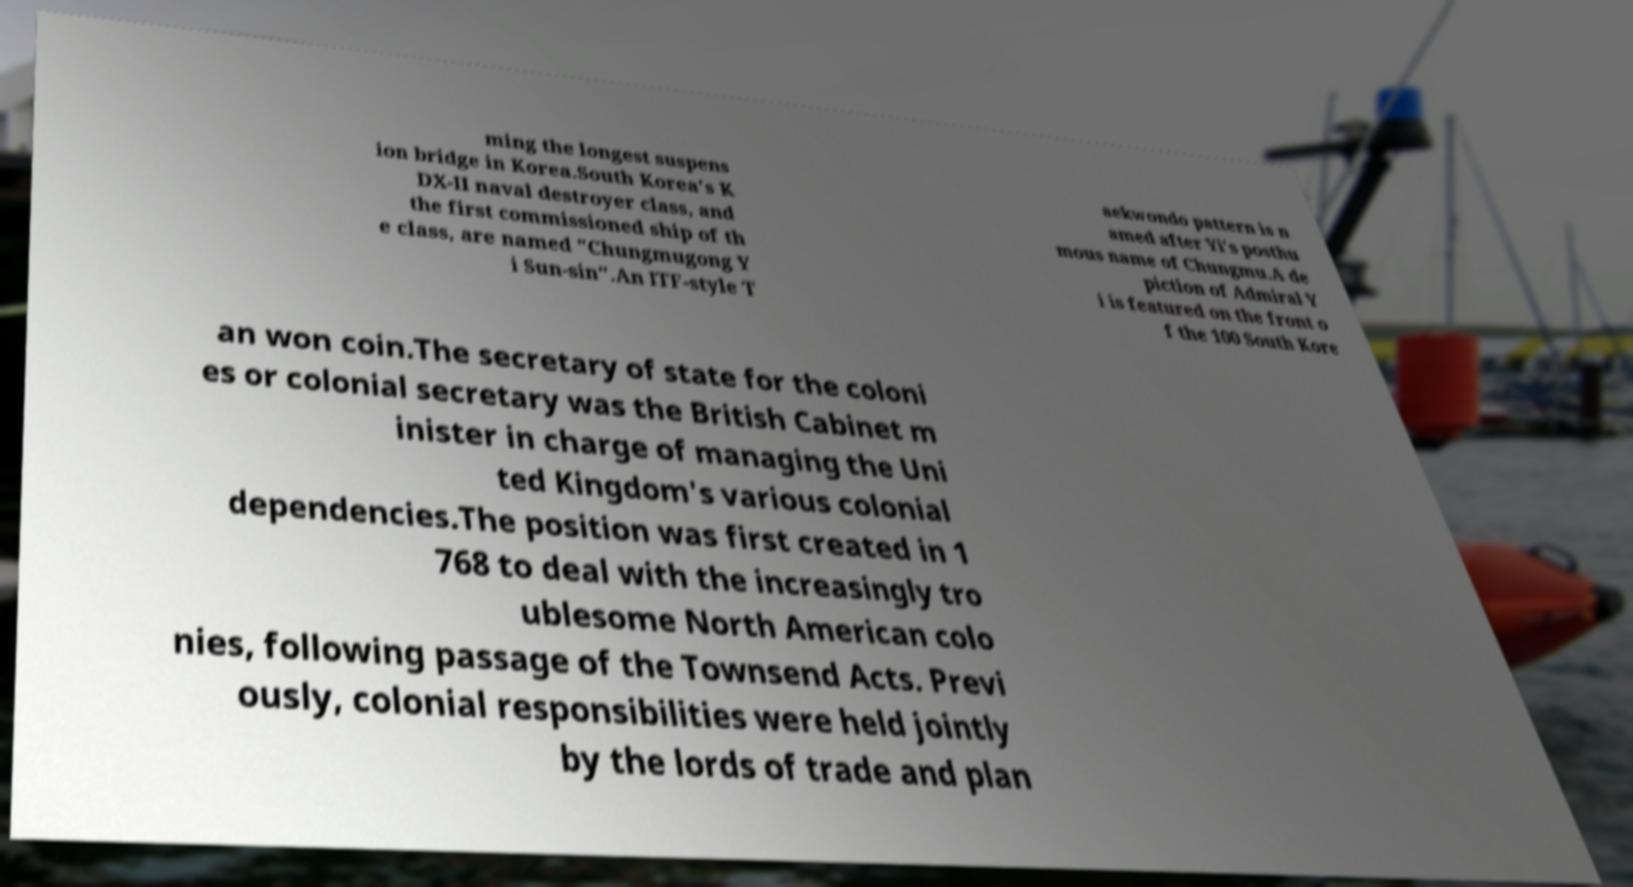I need the written content from this picture converted into text. Can you do that? ming the longest suspens ion bridge in Korea.South Korea's K DX-II naval destroyer class, and the first commissioned ship of th e class, are named "Chungmugong Y i Sun-sin".An ITF-style T aekwondo pattern is n amed after Yi's posthu mous name of Chungmu.A de piction of Admiral Y i is featured on the front o f the 100 South Kore an won coin.The secretary of state for the coloni es or colonial secretary was the British Cabinet m inister in charge of managing the Uni ted Kingdom's various colonial dependencies.The position was first created in 1 768 to deal with the increasingly tro ublesome North American colo nies, following passage of the Townsend Acts. Previ ously, colonial responsibilities were held jointly by the lords of trade and plan 